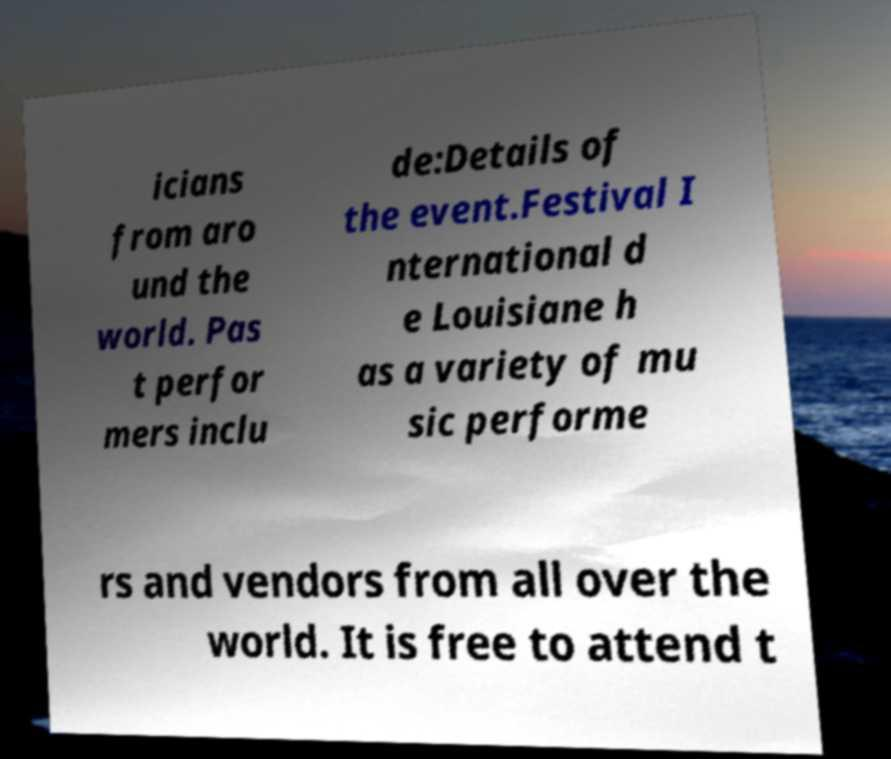For documentation purposes, I need the text within this image transcribed. Could you provide that? icians from aro und the world. Pas t perfor mers inclu de:Details of the event.Festival I nternational d e Louisiane h as a variety of mu sic performe rs and vendors from all over the world. It is free to attend t 